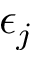<formula> <loc_0><loc_0><loc_500><loc_500>\epsilon _ { j }</formula> 